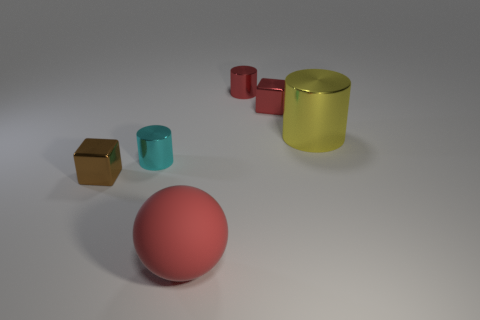What number of objects are behind the red rubber ball and on the left side of the yellow cylinder?
Your answer should be compact. 4. What material is the tiny cyan object?
Your answer should be very brief. Metal. Is there any other thing of the same color as the large rubber object?
Ensure brevity in your answer.  Yes. Do the small brown cube and the yellow thing have the same material?
Offer a very short reply. Yes. There is a large red object that is in front of the cube that is to the left of the red matte sphere; what number of cylinders are to the left of it?
Your response must be concise. 1. What number of small blue metallic things are there?
Your response must be concise. 0. Are there fewer tiny red cylinders in front of the brown block than large red things behind the tiny red metallic cylinder?
Your response must be concise. No. Is the number of large yellow objects that are to the right of the yellow shiny cylinder less than the number of tiny cylinders?
Your response must be concise. Yes. There is a object behind the block right of the tiny metal cube to the left of the tiny red block; what is it made of?
Provide a succinct answer. Metal. How many objects are either shiny cylinders that are to the left of the red cylinder or shiny cylinders to the right of the ball?
Ensure brevity in your answer.  3. 